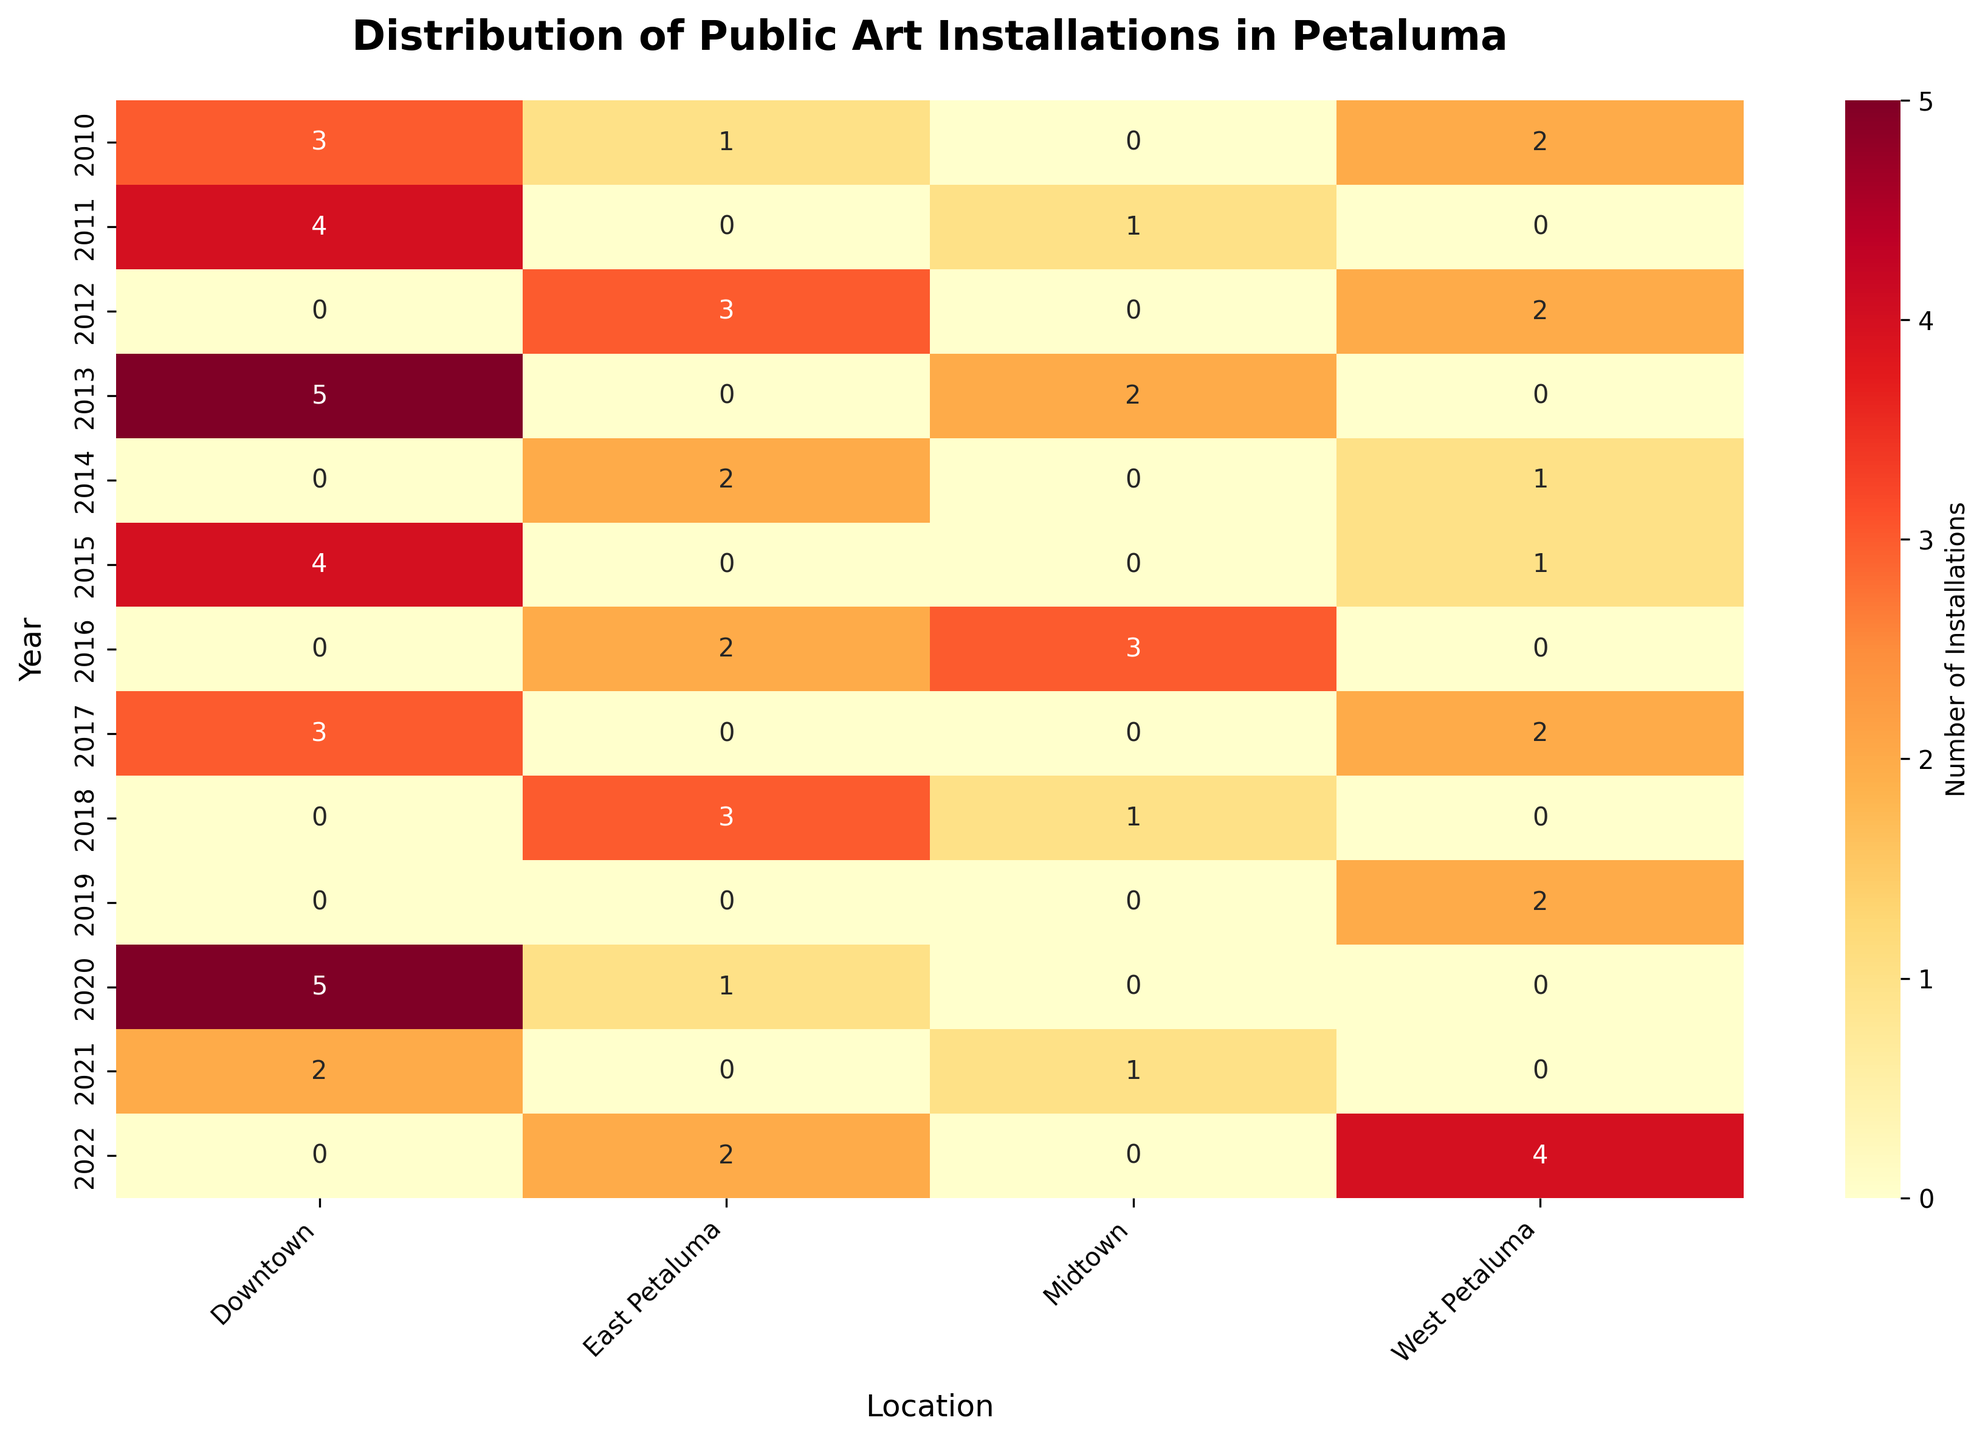what is the title of the heatmap? The title of the heatmap is usually displayed at the top center of the plot. In this case, it reads "Distribution of Public Art Installations in Petaluma."
Answer: Distribution of Public Art Installations in Petaluma which location had the most art installations in 2020? To find the location with the most art installations in 2020, look at the row corresponding to the year 2020 and see which column has the highest value.
Answer: Downtown how many total art installations were there in East Petaluma from 2010 to 2022? Sum all the values in the "East Petaluma" column from 2010 to 2022: 1 + 3 + 2 + 2 + 2 + 1 + 3 + 2 = 16.
Answer: 16 which year saw the highest number of total art installations? Sum the values for each year and find the year with the maximum sum. For example: 3+1+2 (2010), 4+1 (2011), etc. The year 2020 has the highest sum of 6.
Answer: 2020 were there any years where Midtown had no art installations? Look at the "Midtown" column and check for rows with a value of 0. Midtown had no installations in 2010, 2011, 2014, 2015, 2017, 2019, 2020, and 2022.
Answer: Yes how many more art installations were in Downtown compared to West Petaluma in 2013? Compare the values for Downtown and West Petaluma in the year 2013. Downtown had 5 installations, and West Petaluma had 0, so the difference is 5 - 0.
Answer: 5 which location had the highest increase in installations from 2010 to 2022? Calculate the difference in the number of installations between 2022 and 2010 for each location. Downtown: 2 - 3 = -1, East Petaluma: 2 - 1 = 1, West Petaluma: 4 - 2 = 2, Midtown: 0 - 0 = 0. West Petaluma had the highest increase.
Answer: West Petaluma is there a year where Downtown had fewer than 3 installations? Check the values in the Downtown column to see if there are any years with values below 3. Years 2010, 2017, and 2021 have values of 3, 3, and 2, respectively. Only 2021 fits the criteria.
Answer: Yes, 2021 which location had the most consistent number of installations over the years? Assess the variance in installation numbers for each location. There is no need for calculations, just a visual inspection shows that Midtown had the least variation compared to other locations.
Answer: Midtown 